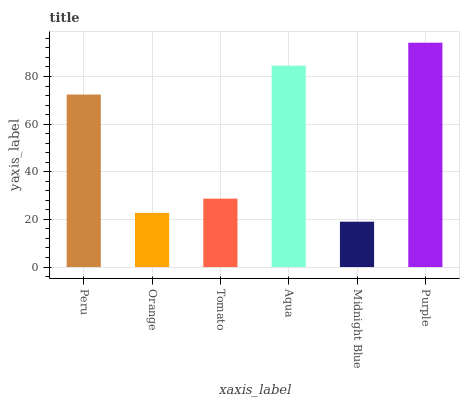Is Midnight Blue the minimum?
Answer yes or no. Yes. Is Purple the maximum?
Answer yes or no. Yes. Is Orange the minimum?
Answer yes or no. No. Is Orange the maximum?
Answer yes or no. No. Is Peru greater than Orange?
Answer yes or no. Yes. Is Orange less than Peru?
Answer yes or no. Yes. Is Orange greater than Peru?
Answer yes or no. No. Is Peru less than Orange?
Answer yes or no. No. Is Peru the high median?
Answer yes or no. Yes. Is Tomato the low median?
Answer yes or no. Yes. Is Tomato the high median?
Answer yes or no. No. Is Purple the low median?
Answer yes or no. No. 